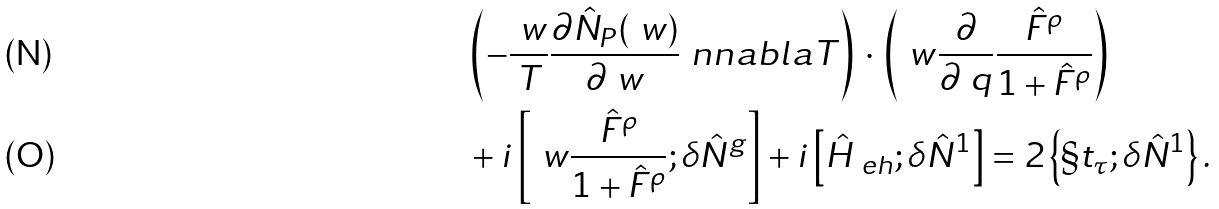Convert formula to latex. <formula><loc_0><loc_0><loc_500><loc_500>& \left ( - \frac { \ w } { T } \frac { \partial \hat { N } _ { P } ( \ w ) } { \partial \ w } \ n n a b l a T \right ) \, \cdot \, \left ( \ w \frac { \partial } { \partial \ q } \frac { \hat { F } ^ { \rho } } { 1 + \hat { F } ^ { \rho } } \right ) \\ & + i \left [ \ w \frac { \hat { F } ^ { \rho } } { 1 + \hat { F } ^ { \rho } } ; \delta \hat { N } ^ { g } \right ] + i \left [ \hat { H } _ { \ e h } ; \delta \hat { N } ^ { 1 } \right ] = 2 \left \{ \S t _ { \tau } ; \delta \hat { N } ^ { 1 } \right \} .</formula> 